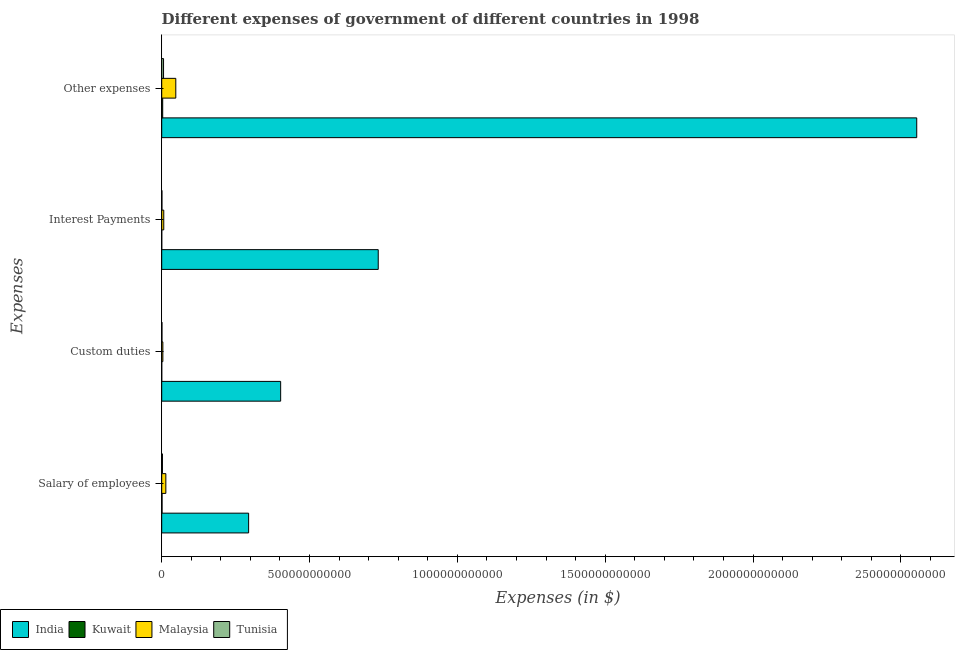How many different coloured bars are there?
Your answer should be compact. 4. Are the number of bars per tick equal to the number of legend labels?
Offer a very short reply. Yes. Are the number of bars on each tick of the Y-axis equal?
Provide a short and direct response. Yes. How many bars are there on the 2nd tick from the top?
Offer a terse response. 4. What is the label of the 4th group of bars from the top?
Your answer should be compact. Salary of employees. What is the amount spent on salary of employees in Malaysia?
Your answer should be compact. 1.40e+1. Across all countries, what is the maximum amount spent on custom duties?
Provide a succinct answer. 4.02e+11. Across all countries, what is the minimum amount spent on salary of employees?
Give a very brief answer. 1.17e+09. In which country was the amount spent on salary of employees minimum?
Ensure brevity in your answer.  Kuwait. What is the total amount spent on salary of employees in the graph?
Offer a very short reply. 3.12e+11. What is the difference between the amount spent on interest payments in Kuwait and that in Malaysia?
Offer a terse response. -6.79e+09. What is the difference between the amount spent on interest payments in Malaysia and the amount spent on custom duties in Kuwait?
Provide a succinct answer. 6.84e+09. What is the average amount spent on salary of employees per country?
Give a very brief answer. 7.79e+1. What is the difference between the amount spent on salary of employees and amount spent on custom duties in Tunisia?
Your answer should be very brief. 1.65e+09. What is the ratio of the amount spent on salary of employees in Malaysia to that in Tunisia?
Offer a terse response. 5.52. Is the difference between the amount spent on other expenses in Tunisia and India greater than the difference between the amount spent on interest payments in Tunisia and India?
Your response must be concise. No. What is the difference between the highest and the second highest amount spent on other expenses?
Your answer should be compact. 2.51e+12. What is the difference between the highest and the lowest amount spent on other expenses?
Offer a terse response. 2.55e+12. Is the sum of the amount spent on other expenses in India and Malaysia greater than the maximum amount spent on interest payments across all countries?
Offer a terse response. Yes. What does the 3rd bar from the top in Interest Payments represents?
Offer a terse response. Kuwait. What does the 4th bar from the bottom in Salary of employees represents?
Offer a terse response. Tunisia. How many bars are there?
Provide a short and direct response. 16. How many countries are there in the graph?
Your answer should be very brief. 4. What is the difference between two consecutive major ticks on the X-axis?
Provide a short and direct response. 5.00e+11. Are the values on the major ticks of X-axis written in scientific E-notation?
Keep it short and to the point. No. Does the graph contain grids?
Your answer should be very brief. No. Where does the legend appear in the graph?
Provide a succinct answer. Bottom left. What is the title of the graph?
Keep it short and to the point. Different expenses of government of different countries in 1998. What is the label or title of the X-axis?
Your response must be concise. Expenses (in $). What is the label or title of the Y-axis?
Your response must be concise. Expenses. What is the Expenses (in $) of India in Salary of employees?
Your answer should be very brief. 2.94e+11. What is the Expenses (in $) in Kuwait in Salary of employees?
Your response must be concise. 1.17e+09. What is the Expenses (in $) of Malaysia in Salary of employees?
Provide a succinct answer. 1.40e+1. What is the Expenses (in $) in Tunisia in Salary of employees?
Keep it short and to the point. 2.53e+09. What is the Expenses (in $) of India in Custom duties?
Offer a very short reply. 4.02e+11. What is the Expenses (in $) in Kuwait in Custom duties?
Your response must be concise. 8.30e+07. What is the Expenses (in $) in Malaysia in Custom duties?
Give a very brief answer. 3.87e+09. What is the Expenses (in $) in Tunisia in Custom duties?
Provide a short and direct response. 8.79e+08. What is the Expenses (in $) of India in Interest Payments?
Make the answer very short. 7.32e+11. What is the Expenses (in $) in Kuwait in Interest Payments?
Offer a terse response. 1.34e+08. What is the Expenses (in $) of Malaysia in Interest Payments?
Ensure brevity in your answer.  6.93e+09. What is the Expenses (in $) of Tunisia in Interest Payments?
Make the answer very short. 7.70e+08. What is the Expenses (in $) of India in Other expenses?
Keep it short and to the point. 2.55e+12. What is the Expenses (in $) of Kuwait in Other expenses?
Your response must be concise. 3.33e+09. What is the Expenses (in $) in Malaysia in Other expenses?
Provide a succinct answer. 4.76e+1. What is the Expenses (in $) of Tunisia in Other expenses?
Provide a succinct answer. 6.19e+09. Across all Expenses, what is the maximum Expenses (in $) in India?
Give a very brief answer. 2.55e+12. Across all Expenses, what is the maximum Expenses (in $) of Kuwait?
Your response must be concise. 3.33e+09. Across all Expenses, what is the maximum Expenses (in $) of Malaysia?
Make the answer very short. 4.76e+1. Across all Expenses, what is the maximum Expenses (in $) in Tunisia?
Your response must be concise. 6.19e+09. Across all Expenses, what is the minimum Expenses (in $) in India?
Give a very brief answer. 2.94e+11. Across all Expenses, what is the minimum Expenses (in $) of Kuwait?
Offer a very short reply. 8.30e+07. Across all Expenses, what is the minimum Expenses (in $) in Malaysia?
Your answer should be very brief. 3.87e+09. Across all Expenses, what is the minimum Expenses (in $) of Tunisia?
Your response must be concise. 7.70e+08. What is the total Expenses (in $) of India in the graph?
Your answer should be compact. 3.98e+12. What is the total Expenses (in $) of Kuwait in the graph?
Provide a short and direct response. 4.71e+09. What is the total Expenses (in $) in Malaysia in the graph?
Your answer should be very brief. 7.24e+1. What is the total Expenses (in $) of Tunisia in the graph?
Your response must be concise. 1.04e+1. What is the difference between the Expenses (in $) in India in Salary of employees and that in Custom duties?
Keep it short and to the point. -1.08e+11. What is the difference between the Expenses (in $) of Kuwait in Salary of employees and that in Custom duties?
Ensure brevity in your answer.  1.08e+09. What is the difference between the Expenses (in $) in Malaysia in Salary of employees and that in Custom duties?
Keep it short and to the point. 1.01e+1. What is the difference between the Expenses (in $) of Tunisia in Salary of employees and that in Custom duties?
Offer a terse response. 1.65e+09. What is the difference between the Expenses (in $) in India in Salary of employees and that in Interest Payments?
Give a very brief answer. -4.38e+11. What is the difference between the Expenses (in $) of Kuwait in Salary of employees and that in Interest Payments?
Offer a terse response. 1.03e+09. What is the difference between the Expenses (in $) in Malaysia in Salary of employees and that in Interest Payments?
Provide a short and direct response. 7.06e+09. What is the difference between the Expenses (in $) of Tunisia in Salary of employees and that in Interest Payments?
Provide a short and direct response. 1.76e+09. What is the difference between the Expenses (in $) of India in Salary of employees and that in Other expenses?
Your response must be concise. -2.26e+12. What is the difference between the Expenses (in $) in Kuwait in Salary of employees and that in Other expenses?
Give a very brief answer. -2.16e+09. What is the difference between the Expenses (in $) in Malaysia in Salary of employees and that in Other expenses?
Give a very brief answer. -3.36e+1. What is the difference between the Expenses (in $) in Tunisia in Salary of employees and that in Other expenses?
Keep it short and to the point. -3.65e+09. What is the difference between the Expenses (in $) in India in Custom duties and that in Interest Payments?
Your answer should be compact. -3.30e+11. What is the difference between the Expenses (in $) in Kuwait in Custom duties and that in Interest Payments?
Offer a very short reply. -5.10e+07. What is the difference between the Expenses (in $) of Malaysia in Custom duties and that in Interest Payments?
Your answer should be compact. -3.06e+09. What is the difference between the Expenses (in $) in Tunisia in Custom duties and that in Interest Payments?
Your answer should be compact. 1.09e+08. What is the difference between the Expenses (in $) of India in Custom duties and that in Other expenses?
Offer a very short reply. -2.15e+12. What is the difference between the Expenses (in $) in Kuwait in Custom duties and that in Other expenses?
Ensure brevity in your answer.  -3.24e+09. What is the difference between the Expenses (in $) in Malaysia in Custom duties and that in Other expenses?
Your answer should be compact. -4.38e+1. What is the difference between the Expenses (in $) in Tunisia in Custom duties and that in Other expenses?
Provide a short and direct response. -5.31e+09. What is the difference between the Expenses (in $) in India in Interest Payments and that in Other expenses?
Your response must be concise. -1.82e+12. What is the difference between the Expenses (in $) in Kuwait in Interest Payments and that in Other expenses?
Offer a terse response. -3.19e+09. What is the difference between the Expenses (in $) in Malaysia in Interest Payments and that in Other expenses?
Your answer should be compact. -4.07e+1. What is the difference between the Expenses (in $) of Tunisia in Interest Payments and that in Other expenses?
Give a very brief answer. -5.42e+09. What is the difference between the Expenses (in $) of India in Salary of employees and the Expenses (in $) of Kuwait in Custom duties?
Make the answer very short. 2.94e+11. What is the difference between the Expenses (in $) in India in Salary of employees and the Expenses (in $) in Malaysia in Custom duties?
Provide a succinct answer. 2.90e+11. What is the difference between the Expenses (in $) of India in Salary of employees and the Expenses (in $) of Tunisia in Custom duties?
Provide a short and direct response. 2.93e+11. What is the difference between the Expenses (in $) in Kuwait in Salary of employees and the Expenses (in $) in Malaysia in Custom duties?
Provide a succinct answer. -2.70e+09. What is the difference between the Expenses (in $) in Kuwait in Salary of employees and the Expenses (in $) in Tunisia in Custom duties?
Provide a succinct answer. 2.88e+08. What is the difference between the Expenses (in $) of Malaysia in Salary of employees and the Expenses (in $) of Tunisia in Custom duties?
Your answer should be very brief. 1.31e+1. What is the difference between the Expenses (in $) in India in Salary of employees and the Expenses (in $) in Kuwait in Interest Payments?
Keep it short and to the point. 2.94e+11. What is the difference between the Expenses (in $) in India in Salary of employees and the Expenses (in $) in Malaysia in Interest Payments?
Offer a very short reply. 2.87e+11. What is the difference between the Expenses (in $) of India in Salary of employees and the Expenses (in $) of Tunisia in Interest Payments?
Provide a succinct answer. 2.93e+11. What is the difference between the Expenses (in $) of Kuwait in Salary of employees and the Expenses (in $) of Malaysia in Interest Payments?
Offer a terse response. -5.76e+09. What is the difference between the Expenses (in $) of Kuwait in Salary of employees and the Expenses (in $) of Tunisia in Interest Payments?
Offer a terse response. 3.97e+08. What is the difference between the Expenses (in $) of Malaysia in Salary of employees and the Expenses (in $) of Tunisia in Interest Payments?
Give a very brief answer. 1.32e+1. What is the difference between the Expenses (in $) in India in Salary of employees and the Expenses (in $) in Kuwait in Other expenses?
Offer a terse response. 2.91e+11. What is the difference between the Expenses (in $) of India in Salary of employees and the Expenses (in $) of Malaysia in Other expenses?
Ensure brevity in your answer.  2.46e+11. What is the difference between the Expenses (in $) in India in Salary of employees and the Expenses (in $) in Tunisia in Other expenses?
Your answer should be very brief. 2.88e+11. What is the difference between the Expenses (in $) in Kuwait in Salary of employees and the Expenses (in $) in Malaysia in Other expenses?
Your answer should be compact. -4.65e+1. What is the difference between the Expenses (in $) in Kuwait in Salary of employees and the Expenses (in $) in Tunisia in Other expenses?
Make the answer very short. -5.02e+09. What is the difference between the Expenses (in $) in Malaysia in Salary of employees and the Expenses (in $) in Tunisia in Other expenses?
Provide a succinct answer. 7.80e+09. What is the difference between the Expenses (in $) in India in Custom duties and the Expenses (in $) in Kuwait in Interest Payments?
Your response must be concise. 4.02e+11. What is the difference between the Expenses (in $) in India in Custom duties and the Expenses (in $) in Malaysia in Interest Payments?
Keep it short and to the point. 3.95e+11. What is the difference between the Expenses (in $) of India in Custom duties and the Expenses (in $) of Tunisia in Interest Payments?
Provide a succinct answer. 4.01e+11. What is the difference between the Expenses (in $) of Kuwait in Custom duties and the Expenses (in $) of Malaysia in Interest Payments?
Keep it short and to the point. -6.84e+09. What is the difference between the Expenses (in $) in Kuwait in Custom duties and the Expenses (in $) in Tunisia in Interest Payments?
Provide a succinct answer. -6.87e+08. What is the difference between the Expenses (in $) in Malaysia in Custom duties and the Expenses (in $) in Tunisia in Interest Payments?
Keep it short and to the point. 3.10e+09. What is the difference between the Expenses (in $) of India in Custom duties and the Expenses (in $) of Kuwait in Other expenses?
Your answer should be very brief. 3.99e+11. What is the difference between the Expenses (in $) of India in Custom duties and the Expenses (in $) of Malaysia in Other expenses?
Your answer should be compact. 3.55e+11. What is the difference between the Expenses (in $) in India in Custom duties and the Expenses (in $) in Tunisia in Other expenses?
Your answer should be compact. 3.96e+11. What is the difference between the Expenses (in $) of Kuwait in Custom duties and the Expenses (in $) of Malaysia in Other expenses?
Your answer should be very brief. -4.75e+1. What is the difference between the Expenses (in $) in Kuwait in Custom duties and the Expenses (in $) in Tunisia in Other expenses?
Provide a succinct answer. -6.10e+09. What is the difference between the Expenses (in $) in Malaysia in Custom duties and the Expenses (in $) in Tunisia in Other expenses?
Offer a very short reply. -2.32e+09. What is the difference between the Expenses (in $) of India in Interest Payments and the Expenses (in $) of Kuwait in Other expenses?
Provide a succinct answer. 7.29e+11. What is the difference between the Expenses (in $) in India in Interest Payments and the Expenses (in $) in Malaysia in Other expenses?
Your answer should be very brief. 6.85e+11. What is the difference between the Expenses (in $) in India in Interest Payments and the Expenses (in $) in Tunisia in Other expenses?
Make the answer very short. 7.26e+11. What is the difference between the Expenses (in $) in Kuwait in Interest Payments and the Expenses (in $) in Malaysia in Other expenses?
Keep it short and to the point. -4.75e+1. What is the difference between the Expenses (in $) of Kuwait in Interest Payments and the Expenses (in $) of Tunisia in Other expenses?
Provide a succinct answer. -6.05e+09. What is the difference between the Expenses (in $) of Malaysia in Interest Payments and the Expenses (in $) of Tunisia in Other expenses?
Provide a short and direct response. 7.43e+08. What is the average Expenses (in $) of India per Expenses?
Ensure brevity in your answer.  9.95e+11. What is the average Expenses (in $) of Kuwait per Expenses?
Your answer should be very brief. 1.18e+09. What is the average Expenses (in $) in Malaysia per Expenses?
Your answer should be compact. 1.81e+1. What is the average Expenses (in $) in Tunisia per Expenses?
Give a very brief answer. 2.59e+09. What is the difference between the Expenses (in $) in India and Expenses (in $) in Kuwait in Salary of employees?
Ensure brevity in your answer.  2.93e+11. What is the difference between the Expenses (in $) in India and Expenses (in $) in Malaysia in Salary of employees?
Give a very brief answer. 2.80e+11. What is the difference between the Expenses (in $) in India and Expenses (in $) in Tunisia in Salary of employees?
Offer a terse response. 2.91e+11. What is the difference between the Expenses (in $) in Kuwait and Expenses (in $) in Malaysia in Salary of employees?
Your answer should be compact. -1.28e+1. What is the difference between the Expenses (in $) of Kuwait and Expenses (in $) of Tunisia in Salary of employees?
Offer a terse response. -1.37e+09. What is the difference between the Expenses (in $) of Malaysia and Expenses (in $) of Tunisia in Salary of employees?
Your answer should be compact. 1.15e+1. What is the difference between the Expenses (in $) of India and Expenses (in $) of Kuwait in Custom duties?
Your answer should be compact. 4.02e+11. What is the difference between the Expenses (in $) in India and Expenses (in $) in Malaysia in Custom duties?
Give a very brief answer. 3.98e+11. What is the difference between the Expenses (in $) in India and Expenses (in $) in Tunisia in Custom duties?
Provide a short and direct response. 4.01e+11. What is the difference between the Expenses (in $) in Kuwait and Expenses (in $) in Malaysia in Custom duties?
Provide a succinct answer. -3.78e+09. What is the difference between the Expenses (in $) in Kuwait and Expenses (in $) in Tunisia in Custom duties?
Ensure brevity in your answer.  -7.96e+08. What is the difference between the Expenses (in $) in Malaysia and Expenses (in $) in Tunisia in Custom duties?
Your answer should be very brief. 2.99e+09. What is the difference between the Expenses (in $) of India and Expenses (in $) of Kuwait in Interest Payments?
Your response must be concise. 7.32e+11. What is the difference between the Expenses (in $) in India and Expenses (in $) in Malaysia in Interest Payments?
Offer a very short reply. 7.25e+11. What is the difference between the Expenses (in $) in India and Expenses (in $) in Tunisia in Interest Payments?
Your response must be concise. 7.32e+11. What is the difference between the Expenses (in $) of Kuwait and Expenses (in $) of Malaysia in Interest Payments?
Make the answer very short. -6.79e+09. What is the difference between the Expenses (in $) of Kuwait and Expenses (in $) of Tunisia in Interest Payments?
Your answer should be compact. -6.36e+08. What is the difference between the Expenses (in $) of Malaysia and Expenses (in $) of Tunisia in Interest Payments?
Provide a succinct answer. 6.16e+09. What is the difference between the Expenses (in $) in India and Expenses (in $) in Kuwait in Other expenses?
Offer a terse response. 2.55e+12. What is the difference between the Expenses (in $) of India and Expenses (in $) of Malaysia in Other expenses?
Your answer should be very brief. 2.51e+12. What is the difference between the Expenses (in $) of India and Expenses (in $) of Tunisia in Other expenses?
Make the answer very short. 2.55e+12. What is the difference between the Expenses (in $) in Kuwait and Expenses (in $) in Malaysia in Other expenses?
Your answer should be compact. -4.43e+1. What is the difference between the Expenses (in $) in Kuwait and Expenses (in $) in Tunisia in Other expenses?
Provide a short and direct response. -2.86e+09. What is the difference between the Expenses (in $) in Malaysia and Expenses (in $) in Tunisia in Other expenses?
Provide a succinct answer. 4.14e+1. What is the ratio of the Expenses (in $) in India in Salary of employees to that in Custom duties?
Keep it short and to the point. 0.73. What is the ratio of the Expenses (in $) in Kuwait in Salary of employees to that in Custom duties?
Your response must be concise. 14.06. What is the ratio of the Expenses (in $) of Malaysia in Salary of employees to that in Custom duties?
Your answer should be very brief. 3.62. What is the ratio of the Expenses (in $) of Tunisia in Salary of employees to that in Custom duties?
Keep it short and to the point. 2.88. What is the ratio of the Expenses (in $) in India in Salary of employees to that in Interest Payments?
Keep it short and to the point. 0.4. What is the ratio of the Expenses (in $) in Kuwait in Salary of employees to that in Interest Payments?
Keep it short and to the point. 8.71. What is the ratio of the Expenses (in $) in Malaysia in Salary of employees to that in Interest Payments?
Give a very brief answer. 2.02. What is the ratio of the Expenses (in $) of Tunisia in Salary of employees to that in Interest Payments?
Your answer should be very brief. 3.29. What is the ratio of the Expenses (in $) of India in Salary of employees to that in Other expenses?
Your response must be concise. 0.12. What is the ratio of the Expenses (in $) in Kuwait in Salary of employees to that in Other expenses?
Provide a succinct answer. 0.35. What is the ratio of the Expenses (in $) of Malaysia in Salary of employees to that in Other expenses?
Make the answer very short. 0.29. What is the ratio of the Expenses (in $) in Tunisia in Salary of employees to that in Other expenses?
Your answer should be very brief. 0.41. What is the ratio of the Expenses (in $) of India in Custom duties to that in Interest Payments?
Offer a very short reply. 0.55. What is the ratio of the Expenses (in $) in Kuwait in Custom duties to that in Interest Payments?
Your answer should be very brief. 0.62. What is the ratio of the Expenses (in $) in Malaysia in Custom duties to that in Interest Payments?
Offer a very short reply. 0.56. What is the ratio of the Expenses (in $) in Tunisia in Custom duties to that in Interest Payments?
Your response must be concise. 1.14. What is the ratio of the Expenses (in $) in India in Custom duties to that in Other expenses?
Offer a very short reply. 0.16. What is the ratio of the Expenses (in $) of Kuwait in Custom duties to that in Other expenses?
Offer a terse response. 0.02. What is the ratio of the Expenses (in $) in Malaysia in Custom duties to that in Other expenses?
Keep it short and to the point. 0.08. What is the ratio of the Expenses (in $) in Tunisia in Custom duties to that in Other expenses?
Give a very brief answer. 0.14. What is the ratio of the Expenses (in $) in India in Interest Payments to that in Other expenses?
Ensure brevity in your answer.  0.29. What is the ratio of the Expenses (in $) in Kuwait in Interest Payments to that in Other expenses?
Give a very brief answer. 0.04. What is the ratio of the Expenses (in $) in Malaysia in Interest Payments to that in Other expenses?
Your response must be concise. 0.15. What is the ratio of the Expenses (in $) of Tunisia in Interest Payments to that in Other expenses?
Your answer should be compact. 0.12. What is the difference between the highest and the second highest Expenses (in $) in India?
Your answer should be compact. 1.82e+12. What is the difference between the highest and the second highest Expenses (in $) in Kuwait?
Provide a short and direct response. 2.16e+09. What is the difference between the highest and the second highest Expenses (in $) of Malaysia?
Your answer should be compact. 3.36e+1. What is the difference between the highest and the second highest Expenses (in $) in Tunisia?
Provide a succinct answer. 3.65e+09. What is the difference between the highest and the lowest Expenses (in $) in India?
Offer a terse response. 2.26e+12. What is the difference between the highest and the lowest Expenses (in $) of Kuwait?
Make the answer very short. 3.24e+09. What is the difference between the highest and the lowest Expenses (in $) in Malaysia?
Your answer should be compact. 4.38e+1. What is the difference between the highest and the lowest Expenses (in $) in Tunisia?
Provide a short and direct response. 5.42e+09. 